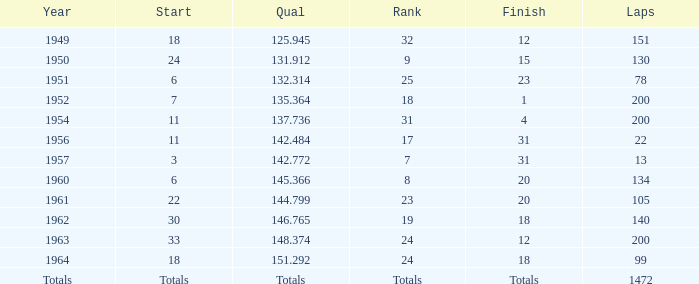Name the rank with laps of 200 and qual of 148.374 24.0. 